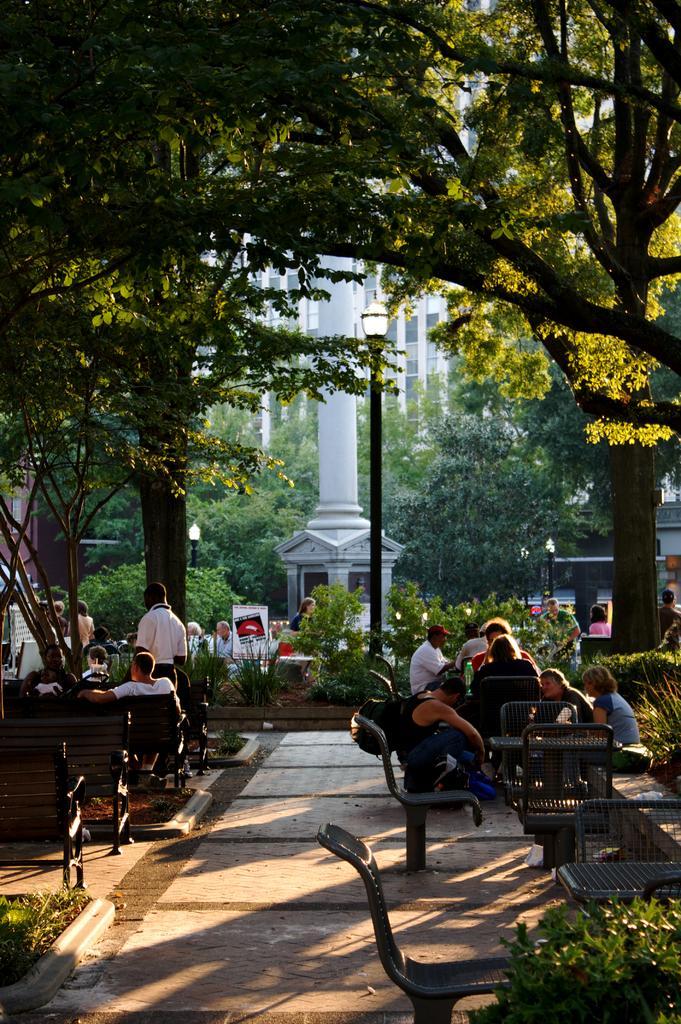Could you give a brief overview of what you see in this image? In this picture we can see group of people some are sitting on chair and some are standing and in front of them there is table and in background we can see trees, building, pole, traffic signal, banner. 